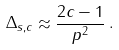<formula> <loc_0><loc_0><loc_500><loc_500>\Delta _ { s , c } \approx \frac { 2 c - 1 } { p ^ { 2 } } \, .</formula> 